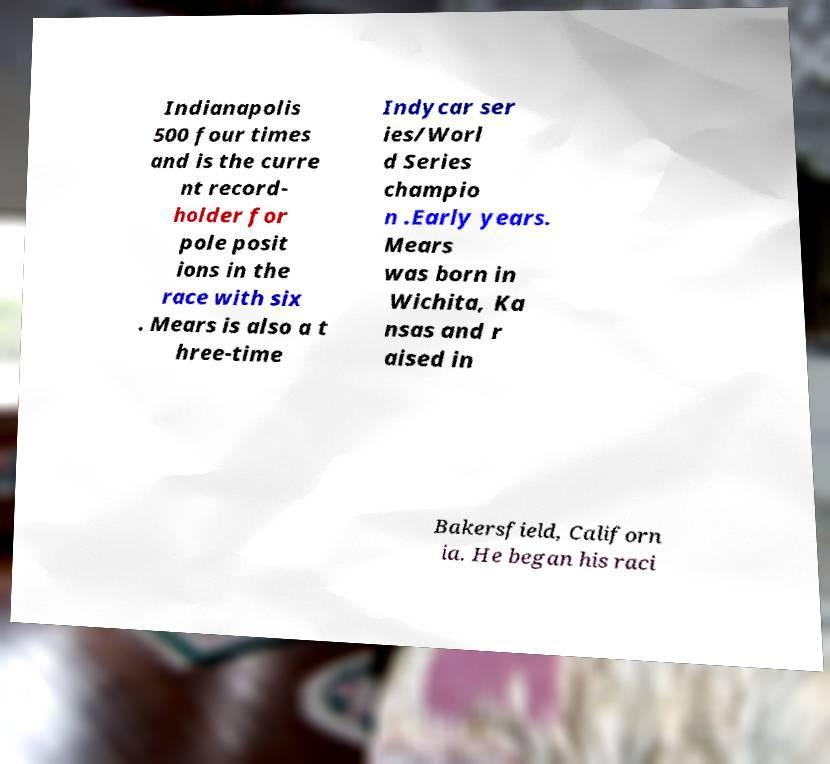Please identify and transcribe the text found in this image. Indianapolis 500 four times and is the curre nt record- holder for pole posit ions in the race with six . Mears is also a t hree-time Indycar ser ies/Worl d Series champio n .Early years. Mears was born in Wichita, Ka nsas and r aised in Bakersfield, Californ ia. He began his raci 